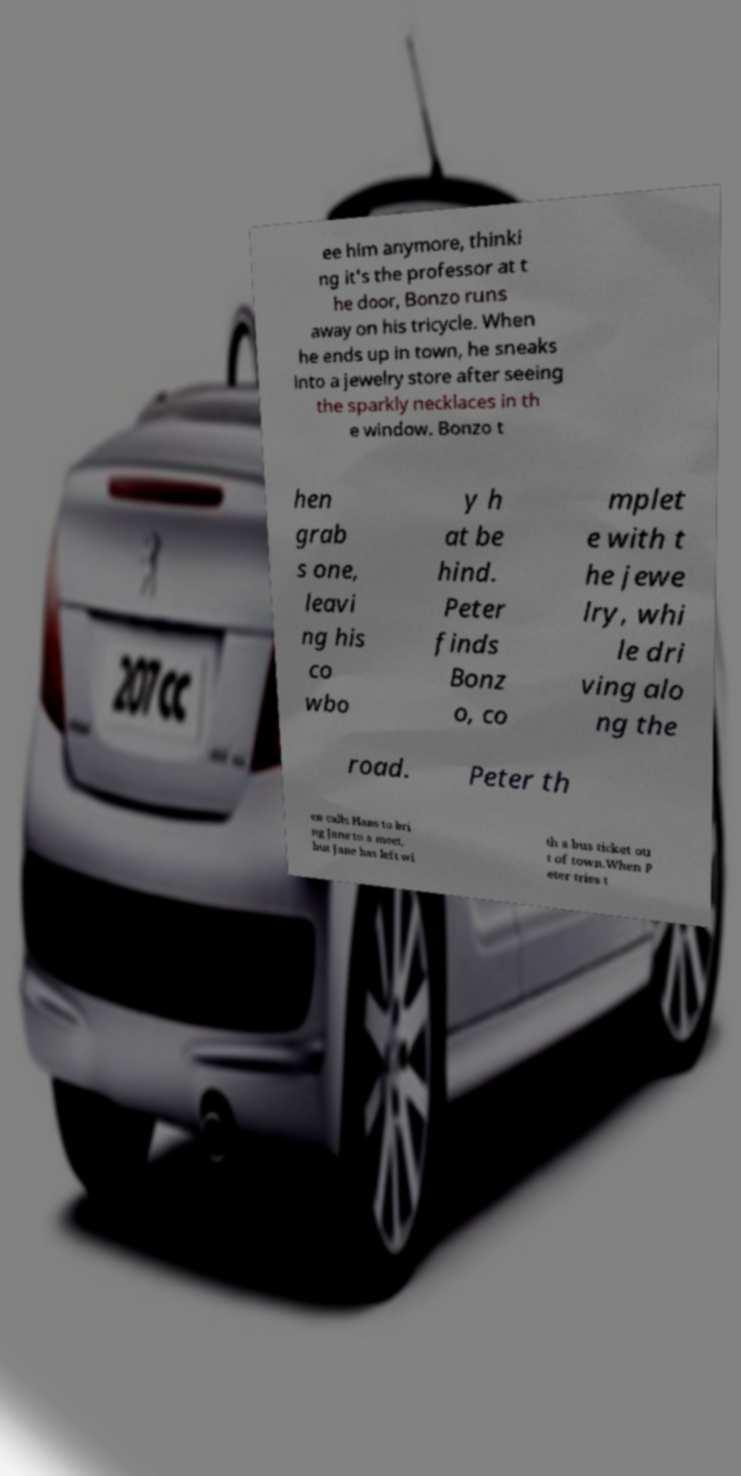For documentation purposes, I need the text within this image transcribed. Could you provide that? ee him anymore, thinki ng it's the professor at t he door, Bonzo runs away on his tricycle. When he ends up in town, he sneaks into a jewelry store after seeing the sparkly necklaces in th e window. Bonzo t hen grab s one, leavi ng his co wbo y h at be hind. Peter finds Bonz o, co mplet e with t he jewe lry, whi le dri ving alo ng the road. Peter th en calls Hans to bri ng Jane to a meet, but Jane has left wi th a bus ticket ou t of town.When P eter tries t 